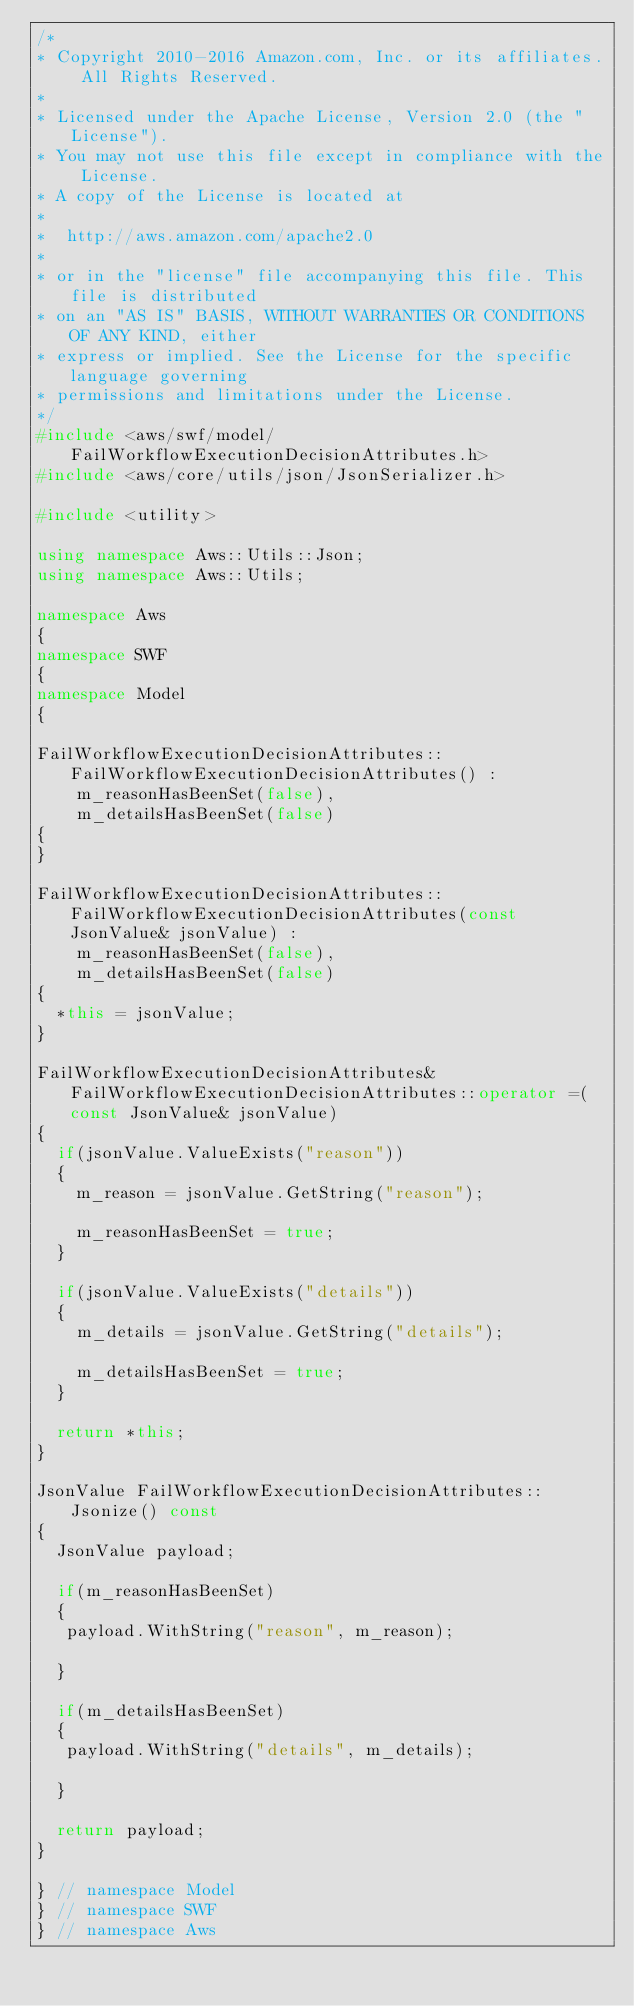Convert code to text. <code><loc_0><loc_0><loc_500><loc_500><_C++_>/*
* Copyright 2010-2016 Amazon.com, Inc. or its affiliates. All Rights Reserved.
*
* Licensed under the Apache License, Version 2.0 (the "License").
* You may not use this file except in compliance with the License.
* A copy of the License is located at
*
*  http://aws.amazon.com/apache2.0
*
* or in the "license" file accompanying this file. This file is distributed
* on an "AS IS" BASIS, WITHOUT WARRANTIES OR CONDITIONS OF ANY KIND, either
* express or implied. See the License for the specific language governing
* permissions and limitations under the License.
*/
#include <aws/swf/model/FailWorkflowExecutionDecisionAttributes.h>
#include <aws/core/utils/json/JsonSerializer.h>

#include <utility>

using namespace Aws::Utils::Json;
using namespace Aws::Utils;

namespace Aws
{
namespace SWF
{
namespace Model
{

FailWorkflowExecutionDecisionAttributes::FailWorkflowExecutionDecisionAttributes() : 
    m_reasonHasBeenSet(false),
    m_detailsHasBeenSet(false)
{
}

FailWorkflowExecutionDecisionAttributes::FailWorkflowExecutionDecisionAttributes(const JsonValue& jsonValue) : 
    m_reasonHasBeenSet(false),
    m_detailsHasBeenSet(false)
{
  *this = jsonValue;
}

FailWorkflowExecutionDecisionAttributes& FailWorkflowExecutionDecisionAttributes::operator =(const JsonValue& jsonValue)
{
  if(jsonValue.ValueExists("reason"))
  {
    m_reason = jsonValue.GetString("reason");

    m_reasonHasBeenSet = true;
  }

  if(jsonValue.ValueExists("details"))
  {
    m_details = jsonValue.GetString("details");

    m_detailsHasBeenSet = true;
  }

  return *this;
}

JsonValue FailWorkflowExecutionDecisionAttributes::Jsonize() const
{
  JsonValue payload;

  if(m_reasonHasBeenSet)
  {
   payload.WithString("reason", m_reason);

  }

  if(m_detailsHasBeenSet)
  {
   payload.WithString("details", m_details);

  }

  return payload;
}

} // namespace Model
} // namespace SWF
} // namespace Aws</code> 